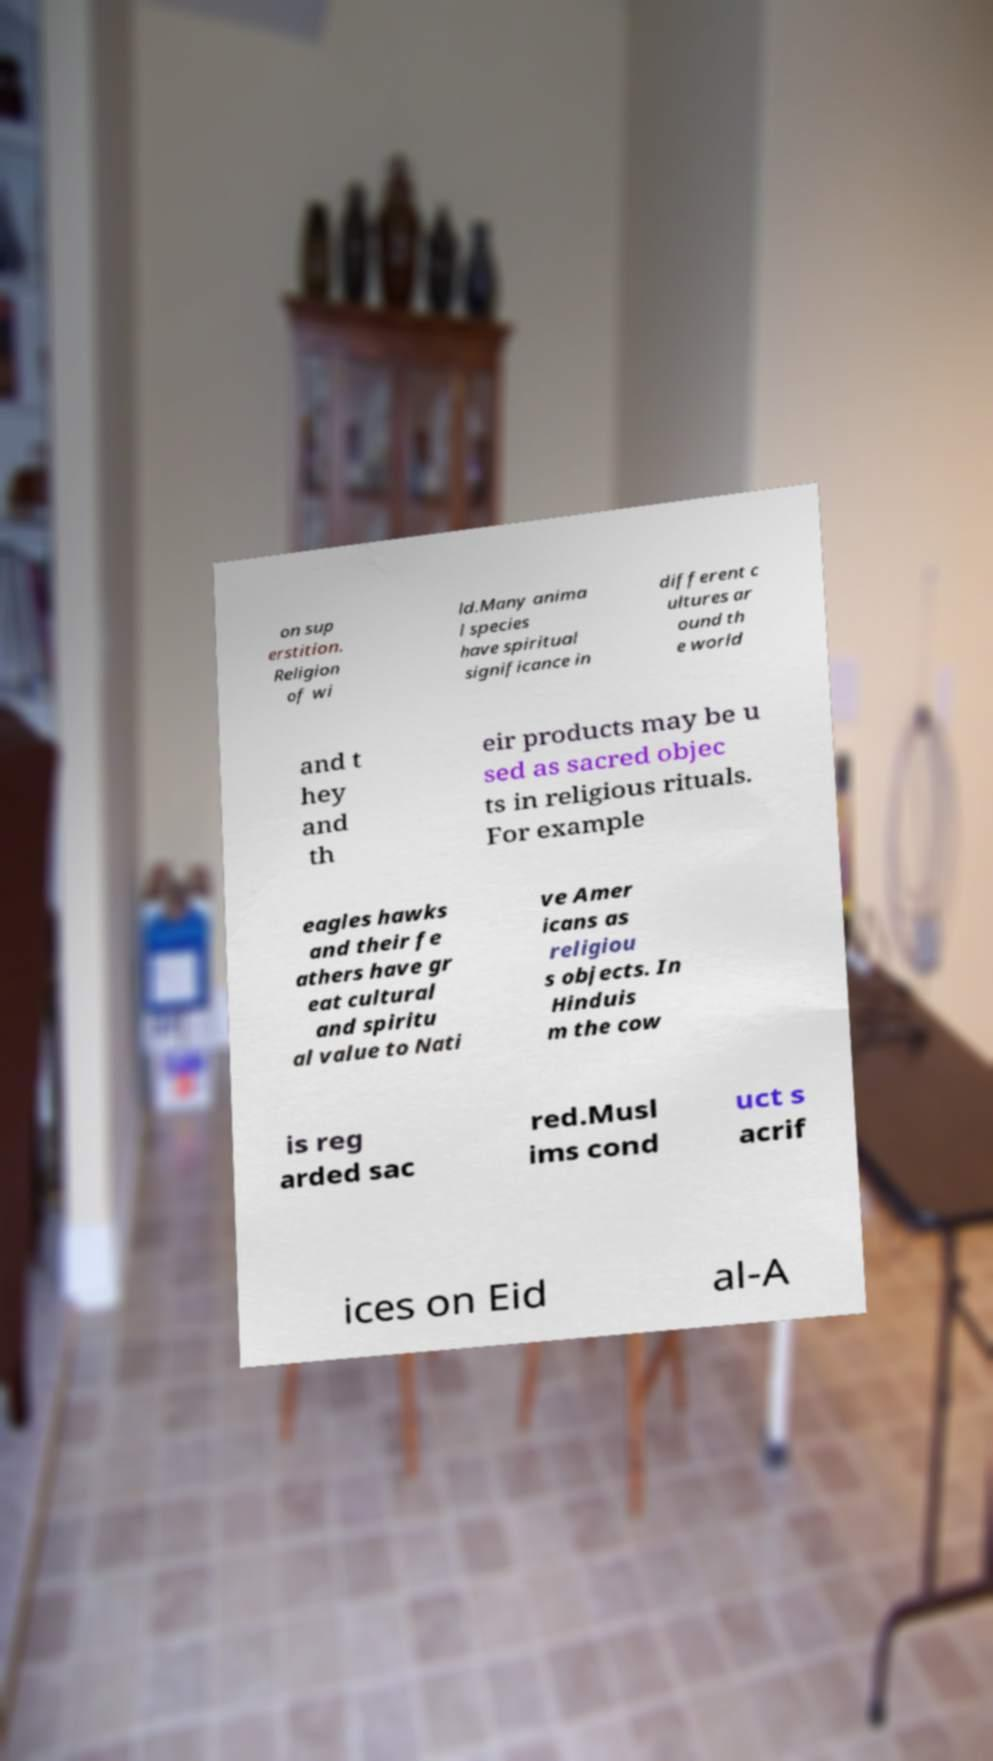Can you read and provide the text displayed in the image?This photo seems to have some interesting text. Can you extract and type it out for me? on sup erstition. Religion of wi ld.Many anima l species have spiritual significance in different c ultures ar ound th e world and t hey and th eir products may be u sed as sacred objec ts in religious rituals. For example eagles hawks and their fe athers have gr eat cultural and spiritu al value to Nati ve Amer icans as religiou s objects. In Hinduis m the cow is reg arded sac red.Musl ims cond uct s acrif ices on Eid al-A 